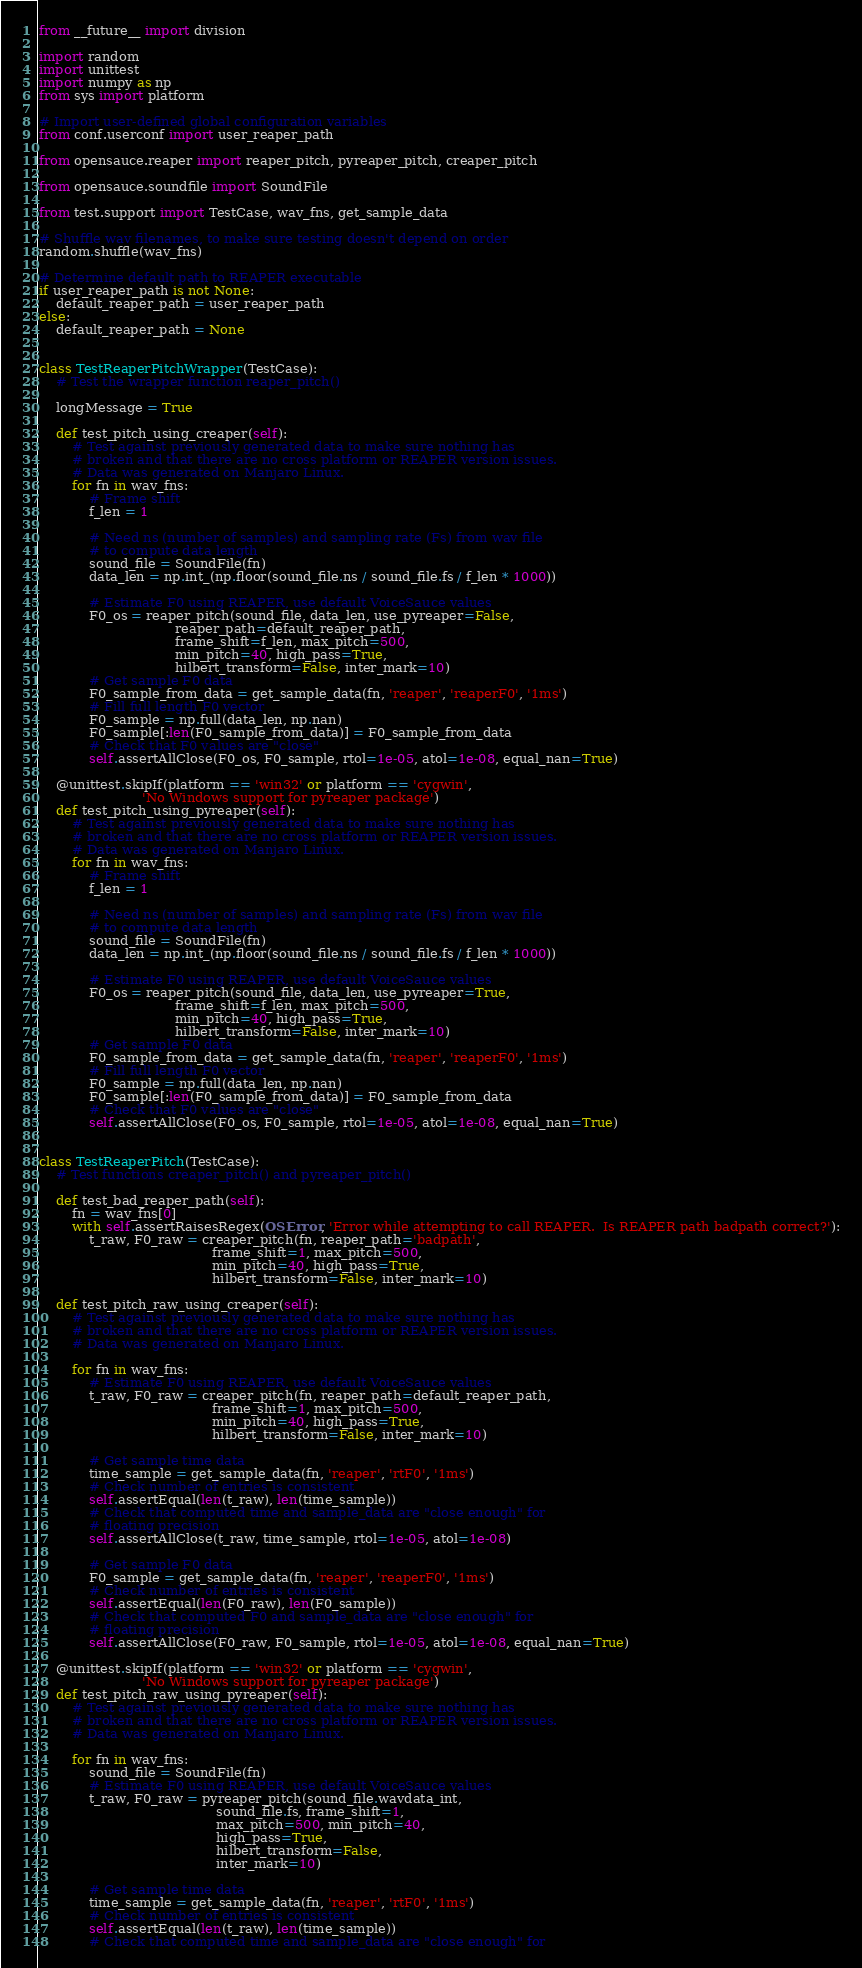<code> <loc_0><loc_0><loc_500><loc_500><_Python_>from __future__ import division

import random
import unittest
import numpy as np
from sys import platform

# Import user-defined global configuration variables
from conf.userconf import user_reaper_path

from opensauce.reaper import reaper_pitch, pyreaper_pitch, creaper_pitch

from opensauce.soundfile import SoundFile

from test.support import TestCase, wav_fns, get_sample_data

# Shuffle wav filenames, to make sure testing doesn't depend on order
random.shuffle(wav_fns)

# Determine default path to REAPER executable
if user_reaper_path is not None:
    default_reaper_path = user_reaper_path
else:
    default_reaper_path = None


class TestReaperPitchWrapper(TestCase):
    # Test the wrapper function reaper_pitch()

    longMessage = True

    def test_pitch_using_creaper(self):
        # Test against previously generated data to make sure nothing has
        # broken and that there are no cross platform or REAPER version issues.
        # Data was generated on Manjaro Linux.
        for fn in wav_fns:
            # Frame shift
            f_len = 1

            # Need ns (number of samples) and sampling rate (Fs) from wav file
            # to compute data length
            sound_file = SoundFile(fn)
            data_len = np.int_(np.floor(sound_file.ns / sound_file.fs / f_len * 1000))

            # Estimate F0 using REAPER, use default VoiceSauce values
            F0_os = reaper_pitch(sound_file, data_len, use_pyreaper=False,
                                 reaper_path=default_reaper_path,
                                 frame_shift=f_len, max_pitch=500,
                                 min_pitch=40, high_pass=True,
                                 hilbert_transform=False, inter_mark=10)
            # Get sample F0 data
            F0_sample_from_data = get_sample_data(fn, 'reaper', 'reaperF0', '1ms')
            # Fill full length F0 vector
            F0_sample = np.full(data_len, np.nan)
            F0_sample[:len(F0_sample_from_data)] = F0_sample_from_data
            # Check that F0 values are "close"
            self.assertAllClose(F0_os, F0_sample, rtol=1e-05, atol=1e-08, equal_nan=True)

    @unittest.skipIf(platform == 'win32' or platform == 'cygwin',
                         'No Windows support for pyreaper package')
    def test_pitch_using_pyreaper(self):
        # Test against previously generated data to make sure nothing has
        # broken and that there are no cross platform or REAPER version issues.
        # Data was generated on Manjaro Linux.
        for fn in wav_fns:
            # Frame shift
            f_len = 1

            # Need ns (number of samples) and sampling rate (Fs) from wav file
            # to compute data length
            sound_file = SoundFile(fn)
            data_len = np.int_(np.floor(sound_file.ns / sound_file.fs / f_len * 1000))

            # Estimate F0 using REAPER, use default VoiceSauce values
            F0_os = reaper_pitch(sound_file, data_len, use_pyreaper=True,
                                 frame_shift=f_len, max_pitch=500,
                                 min_pitch=40, high_pass=True,
                                 hilbert_transform=False, inter_mark=10)
            # Get sample F0 data
            F0_sample_from_data = get_sample_data(fn, 'reaper', 'reaperF0', '1ms')
            # Fill full length F0 vector
            F0_sample = np.full(data_len, np.nan)
            F0_sample[:len(F0_sample_from_data)] = F0_sample_from_data
            # Check that F0 values are "close"
            self.assertAllClose(F0_os, F0_sample, rtol=1e-05, atol=1e-08, equal_nan=True)


class TestReaperPitch(TestCase):
    # Test functions creaper_pitch() and pyreaper_pitch()

    def test_bad_reaper_path(self):
        fn = wav_fns[0]
        with self.assertRaisesRegex(OSError, 'Error while attempting to call REAPER.  Is REAPER path badpath correct?'):
            t_raw, F0_raw = creaper_pitch(fn, reaper_path='badpath',
                                          frame_shift=1, max_pitch=500,
                                          min_pitch=40, high_pass=True,
                                          hilbert_transform=False, inter_mark=10)

    def test_pitch_raw_using_creaper(self):
        # Test against previously generated data to make sure nothing has
        # broken and that there are no cross platform or REAPER version issues.
        # Data was generated on Manjaro Linux.

        for fn in wav_fns:
            # Estimate F0 using REAPER, use default VoiceSauce values
            t_raw, F0_raw = creaper_pitch(fn, reaper_path=default_reaper_path,
                                          frame_shift=1, max_pitch=500,
                                          min_pitch=40, high_pass=True,
                                          hilbert_transform=False, inter_mark=10)

            # Get sample time data
            time_sample = get_sample_data(fn, 'reaper', 'rtF0', '1ms')
            # Check number of entries is consistent
            self.assertEqual(len(t_raw), len(time_sample))
            # Check that computed time and sample_data are "close enough" for
            # floating precision
            self.assertAllClose(t_raw, time_sample, rtol=1e-05, atol=1e-08)

            # Get sample F0 data
            F0_sample = get_sample_data(fn, 'reaper', 'reaperF0', '1ms')
            # Check number of entries is consistent
            self.assertEqual(len(F0_raw), len(F0_sample))
            # Check that computed F0 and sample_data are "close enough" for
            # floating precision
            self.assertAllClose(F0_raw, F0_sample, rtol=1e-05, atol=1e-08, equal_nan=True)

    @unittest.skipIf(platform == 'win32' or platform == 'cygwin',
                         'No Windows support for pyreaper package')
    def test_pitch_raw_using_pyreaper(self):
        # Test against previously generated data to make sure nothing has
        # broken and that there are no cross platform or REAPER version issues.
        # Data was generated on Manjaro Linux.

        for fn in wav_fns:
            sound_file = SoundFile(fn)
            # Estimate F0 using REAPER, use default VoiceSauce values
            t_raw, F0_raw = pyreaper_pitch(sound_file.wavdata_int,
                                           sound_file.fs, frame_shift=1,
                                           max_pitch=500, min_pitch=40,
                                           high_pass=True,
                                           hilbert_transform=False,
                                           inter_mark=10)

            # Get sample time data
            time_sample = get_sample_data(fn, 'reaper', 'rtF0', '1ms')
            # Check number of entries is consistent
            self.assertEqual(len(t_raw), len(time_sample))
            # Check that computed time and sample_data are "close enough" for</code> 